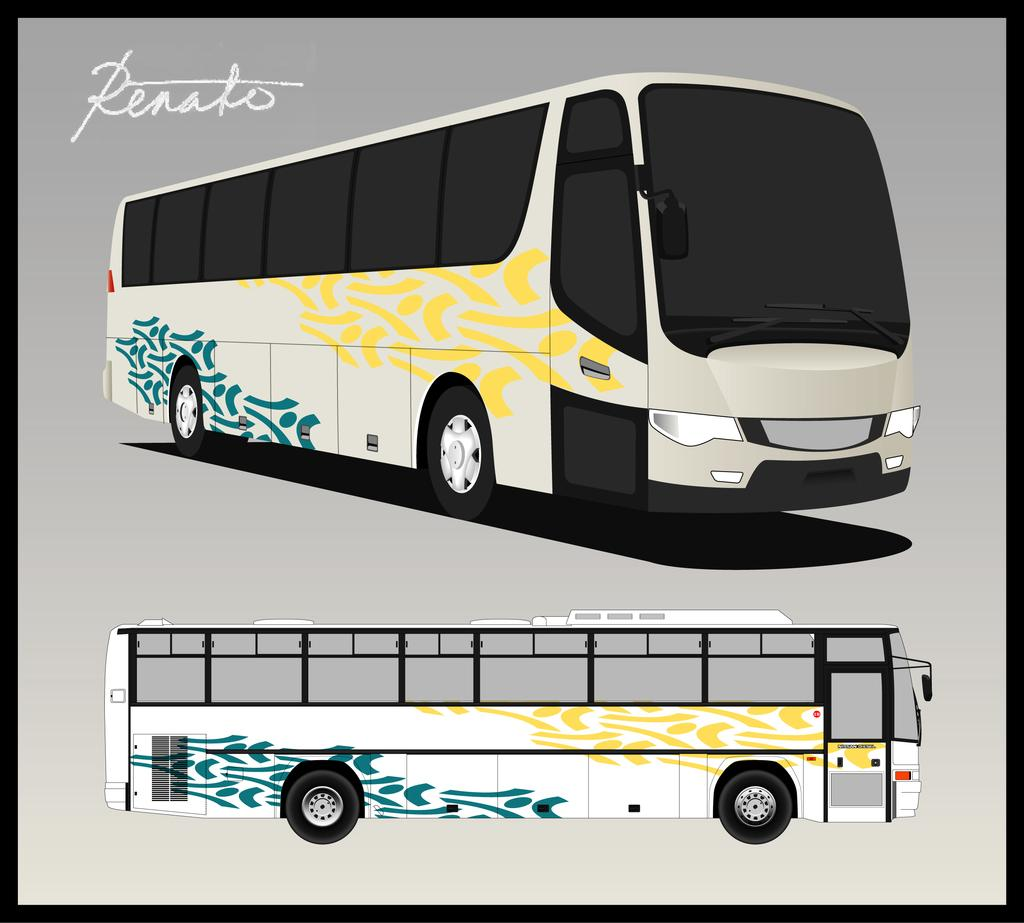<image>
Share a concise interpretation of the image provided. a drawing of a white, blue, and yellow bus made by Renato 